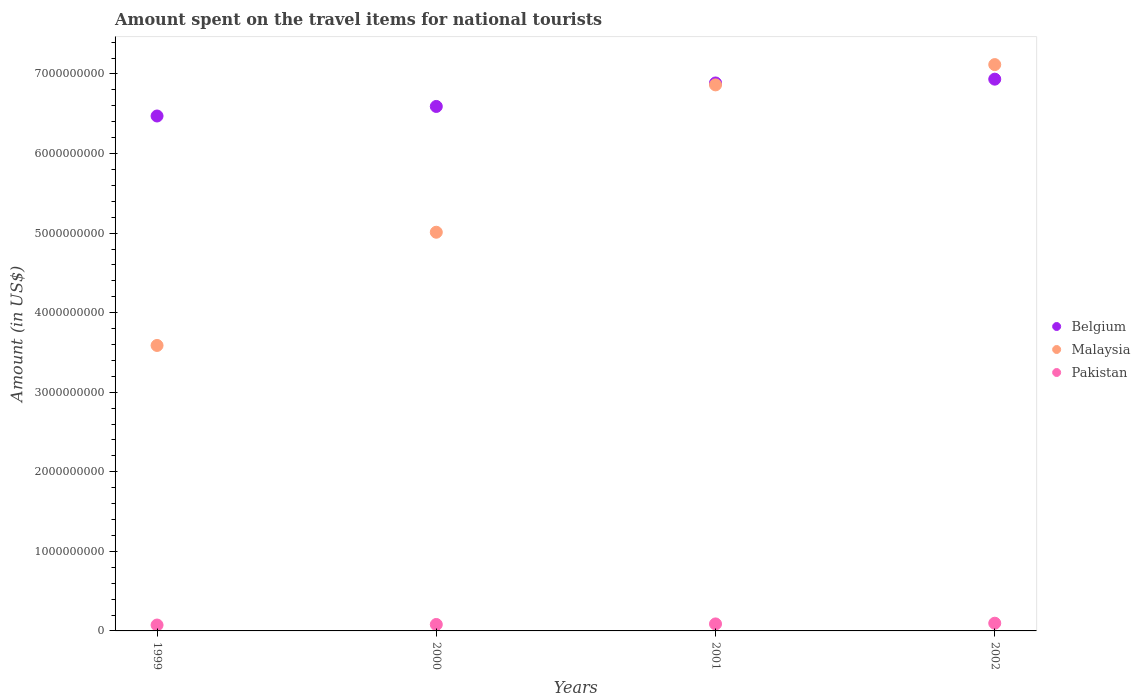How many different coloured dotlines are there?
Offer a terse response. 3. What is the amount spent on the travel items for national tourists in Belgium in 2001?
Make the answer very short. 6.89e+09. Across all years, what is the maximum amount spent on the travel items for national tourists in Belgium?
Keep it short and to the point. 6.94e+09. Across all years, what is the minimum amount spent on the travel items for national tourists in Pakistan?
Offer a terse response. 7.40e+07. What is the total amount spent on the travel items for national tourists in Belgium in the graph?
Your answer should be very brief. 2.69e+1. What is the difference between the amount spent on the travel items for national tourists in Belgium in 2000 and that in 2001?
Your answer should be very brief. -2.95e+08. What is the difference between the amount spent on the travel items for national tourists in Malaysia in 2002 and the amount spent on the travel items for national tourists in Belgium in 2000?
Your answer should be very brief. 5.26e+08. What is the average amount spent on the travel items for national tourists in Belgium per year?
Your response must be concise. 6.72e+09. In the year 2000, what is the difference between the amount spent on the travel items for national tourists in Malaysia and amount spent on the travel items for national tourists in Belgium?
Give a very brief answer. -1.58e+09. In how many years, is the amount spent on the travel items for national tourists in Belgium greater than 3000000000 US$?
Provide a succinct answer. 4. What is the ratio of the amount spent on the travel items for national tourists in Malaysia in 1999 to that in 2001?
Offer a terse response. 0.52. Is the amount spent on the travel items for national tourists in Belgium in 2000 less than that in 2002?
Your answer should be very brief. Yes. Is the difference between the amount spent on the travel items for national tourists in Malaysia in 1999 and 2001 greater than the difference between the amount spent on the travel items for national tourists in Belgium in 1999 and 2001?
Ensure brevity in your answer.  No. What is the difference between the highest and the second highest amount spent on the travel items for national tourists in Belgium?
Give a very brief answer. 4.80e+07. What is the difference between the highest and the lowest amount spent on the travel items for national tourists in Pakistan?
Provide a succinct answer. 2.30e+07. In how many years, is the amount spent on the travel items for national tourists in Belgium greater than the average amount spent on the travel items for national tourists in Belgium taken over all years?
Ensure brevity in your answer.  2. Does the amount spent on the travel items for national tourists in Belgium monotonically increase over the years?
Provide a short and direct response. Yes. Is the amount spent on the travel items for national tourists in Pakistan strictly less than the amount spent on the travel items for national tourists in Malaysia over the years?
Your answer should be compact. Yes. Does the graph contain any zero values?
Your answer should be very brief. No. Where does the legend appear in the graph?
Your answer should be compact. Center right. How are the legend labels stacked?
Keep it short and to the point. Vertical. What is the title of the graph?
Make the answer very short. Amount spent on the travel items for national tourists. Does "Chad" appear as one of the legend labels in the graph?
Provide a short and direct response. No. What is the label or title of the Y-axis?
Keep it short and to the point. Amount (in US$). What is the Amount (in US$) in Belgium in 1999?
Your answer should be compact. 6.47e+09. What is the Amount (in US$) in Malaysia in 1999?
Give a very brief answer. 3.59e+09. What is the Amount (in US$) of Pakistan in 1999?
Your answer should be very brief. 7.40e+07. What is the Amount (in US$) in Belgium in 2000?
Keep it short and to the point. 6.59e+09. What is the Amount (in US$) of Malaysia in 2000?
Your response must be concise. 5.01e+09. What is the Amount (in US$) of Pakistan in 2000?
Offer a terse response. 8.10e+07. What is the Amount (in US$) of Belgium in 2001?
Your answer should be compact. 6.89e+09. What is the Amount (in US$) in Malaysia in 2001?
Your response must be concise. 6.86e+09. What is the Amount (in US$) of Pakistan in 2001?
Your answer should be compact. 8.80e+07. What is the Amount (in US$) of Belgium in 2002?
Keep it short and to the point. 6.94e+09. What is the Amount (in US$) of Malaysia in 2002?
Provide a short and direct response. 7.12e+09. What is the Amount (in US$) of Pakistan in 2002?
Offer a terse response. 9.70e+07. Across all years, what is the maximum Amount (in US$) of Belgium?
Provide a succinct answer. 6.94e+09. Across all years, what is the maximum Amount (in US$) in Malaysia?
Offer a very short reply. 7.12e+09. Across all years, what is the maximum Amount (in US$) in Pakistan?
Ensure brevity in your answer.  9.70e+07. Across all years, what is the minimum Amount (in US$) in Belgium?
Offer a terse response. 6.47e+09. Across all years, what is the minimum Amount (in US$) of Malaysia?
Make the answer very short. 3.59e+09. Across all years, what is the minimum Amount (in US$) of Pakistan?
Provide a short and direct response. 7.40e+07. What is the total Amount (in US$) in Belgium in the graph?
Keep it short and to the point. 2.69e+1. What is the total Amount (in US$) of Malaysia in the graph?
Your answer should be very brief. 2.26e+1. What is the total Amount (in US$) in Pakistan in the graph?
Keep it short and to the point. 3.40e+08. What is the difference between the Amount (in US$) of Belgium in 1999 and that in 2000?
Keep it short and to the point. -1.20e+08. What is the difference between the Amount (in US$) in Malaysia in 1999 and that in 2000?
Your answer should be very brief. -1.42e+09. What is the difference between the Amount (in US$) in Pakistan in 1999 and that in 2000?
Your answer should be very brief. -7.00e+06. What is the difference between the Amount (in US$) in Belgium in 1999 and that in 2001?
Give a very brief answer. -4.15e+08. What is the difference between the Amount (in US$) of Malaysia in 1999 and that in 2001?
Make the answer very short. -3.28e+09. What is the difference between the Amount (in US$) in Pakistan in 1999 and that in 2001?
Offer a very short reply. -1.40e+07. What is the difference between the Amount (in US$) of Belgium in 1999 and that in 2002?
Offer a very short reply. -4.63e+08. What is the difference between the Amount (in US$) of Malaysia in 1999 and that in 2002?
Ensure brevity in your answer.  -3.53e+09. What is the difference between the Amount (in US$) of Pakistan in 1999 and that in 2002?
Offer a terse response. -2.30e+07. What is the difference between the Amount (in US$) in Belgium in 2000 and that in 2001?
Provide a succinct answer. -2.95e+08. What is the difference between the Amount (in US$) in Malaysia in 2000 and that in 2001?
Offer a very short reply. -1.85e+09. What is the difference between the Amount (in US$) of Pakistan in 2000 and that in 2001?
Make the answer very short. -7.00e+06. What is the difference between the Amount (in US$) in Belgium in 2000 and that in 2002?
Make the answer very short. -3.43e+08. What is the difference between the Amount (in US$) in Malaysia in 2000 and that in 2002?
Your response must be concise. -2.11e+09. What is the difference between the Amount (in US$) in Pakistan in 2000 and that in 2002?
Provide a succinct answer. -1.60e+07. What is the difference between the Amount (in US$) in Belgium in 2001 and that in 2002?
Your answer should be very brief. -4.80e+07. What is the difference between the Amount (in US$) of Malaysia in 2001 and that in 2002?
Give a very brief answer. -2.55e+08. What is the difference between the Amount (in US$) of Pakistan in 2001 and that in 2002?
Give a very brief answer. -9.00e+06. What is the difference between the Amount (in US$) in Belgium in 1999 and the Amount (in US$) in Malaysia in 2000?
Offer a terse response. 1.46e+09. What is the difference between the Amount (in US$) of Belgium in 1999 and the Amount (in US$) of Pakistan in 2000?
Make the answer very short. 6.39e+09. What is the difference between the Amount (in US$) of Malaysia in 1999 and the Amount (in US$) of Pakistan in 2000?
Offer a terse response. 3.51e+09. What is the difference between the Amount (in US$) of Belgium in 1999 and the Amount (in US$) of Malaysia in 2001?
Give a very brief answer. -3.91e+08. What is the difference between the Amount (in US$) in Belgium in 1999 and the Amount (in US$) in Pakistan in 2001?
Your response must be concise. 6.38e+09. What is the difference between the Amount (in US$) in Malaysia in 1999 and the Amount (in US$) in Pakistan in 2001?
Offer a terse response. 3.50e+09. What is the difference between the Amount (in US$) of Belgium in 1999 and the Amount (in US$) of Malaysia in 2002?
Your answer should be compact. -6.46e+08. What is the difference between the Amount (in US$) in Belgium in 1999 and the Amount (in US$) in Pakistan in 2002?
Make the answer very short. 6.38e+09. What is the difference between the Amount (in US$) of Malaysia in 1999 and the Amount (in US$) of Pakistan in 2002?
Your response must be concise. 3.49e+09. What is the difference between the Amount (in US$) of Belgium in 2000 and the Amount (in US$) of Malaysia in 2001?
Provide a succinct answer. -2.71e+08. What is the difference between the Amount (in US$) of Belgium in 2000 and the Amount (in US$) of Pakistan in 2001?
Give a very brief answer. 6.50e+09. What is the difference between the Amount (in US$) of Malaysia in 2000 and the Amount (in US$) of Pakistan in 2001?
Give a very brief answer. 4.92e+09. What is the difference between the Amount (in US$) in Belgium in 2000 and the Amount (in US$) in Malaysia in 2002?
Provide a short and direct response. -5.26e+08. What is the difference between the Amount (in US$) of Belgium in 2000 and the Amount (in US$) of Pakistan in 2002?
Offer a terse response. 6.50e+09. What is the difference between the Amount (in US$) in Malaysia in 2000 and the Amount (in US$) in Pakistan in 2002?
Your answer should be compact. 4.91e+09. What is the difference between the Amount (in US$) in Belgium in 2001 and the Amount (in US$) in Malaysia in 2002?
Offer a terse response. -2.31e+08. What is the difference between the Amount (in US$) of Belgium in 2001 and the Amount (in US$) of Pakistan in 2002?
Make the answer very short. 6.79e+09. What is the difference between the Amount (in US$) of Malaysia in 2001 and the Amount (in US$) of Pakistan in 2002?
Give a very brief answer. 6.77e+09. What is the average Amount (in US$) in Belgium per year?
Your response must be concise. 6.72e+09. What is the average Amount (in US$) in Malaysia per year?
Your answer should be very brief. 5.64e+09. What is the average Amount (in US$) of Pakistan per year?
Keep it short and to the point. 8.50e+07. In the year 1999, what is the difference between the Amount (in US$) of Belgium and Amount (in US$) of Malaysia?
Your answer should be very brief. 2.88e+09. In the year 1999, what is the difference between the Amount (in US$) of Belgium and Amount (in US$) of Pakistan?
Provide a succinct answer. 6.40e+09. In the year 1999, what is the difference between the Amount (in US$) in Malaysia and Amount (in US$) in Pakistan?
Give a very brief answer. 3.51e+09. In the year 2000, what is the difference between the Amount (in US$) in Belgium and Amount (in US$) in Malaysia?
Provide a succinct answer. 1.58e+09. In the year 2000, what is the difference between the Amount (in US$) of Belgium and Amount (in US$) of Pakistan?
Keep it short and to the point. 6.51e+09. In the year 2000, what is the difference between the Amount (in US$) in Malaysia and Amount (in US$) in Pakistan?
Offer a very short reply. 4.93e+09. In the year 2001, what is the difference between the Amount (in US$) of Belgium and Amount (in US$) of Malaysia?
Make the answer very short. 2.40e+07. In the year 2001, what is the difference between the Amount (in US$) in Belgium and Amount (in US$) in Pakistan?
Ensure brevity in your answer.  6.80e+09. In the year 2001, what is the difference between the Amount (in US$) of Malaysia and Amount (in US$) of Pakistan?
Ensure brevity in your answer.  6.78e+09. In the year 2002, what is the difference between the Amount (in US$) of Belgium and Amount (in US$) of Malaysia?
Ensure brevity in your answer.  -1.83e+08. In the year 2002, what is the difference between the Amount (in US$) in Belgium and Amount (in US$) in Pakistan?
Your answer should be compact. 6.84e+09. In the year 2002, what is the difference between the Amount (in US$) of Malaysia and Amount (in US$) of Pakistan?
Your answer should be very brief. 7.02e+09. What is the ratio of the Amount (in US$) of Belgium in 1999 to that in 2000?
Offer a very short reply. 0.98. What is the ratio of the Amount (in US$) in Malaysia in 1999 to that in 2000?
Provide a succinct answer. 0.72. What is the ratio of the Amount (in US$) in Pakistan in 1999 to that in 2000?
Your answer should be compact. 0.91. What is the ratio of the Amount (in US$) in Belgium in 1999 to that in 2001?
Provide a succinct answer. 0.94. What is the ratio of the Amount (in US$) of Malaysia in 1999 to that in 2001?
Provide a succinct answer. 0.52. What is the ratio of the Amount (in US$) of Pakistan in 1999 to that in 2001?
Give a very brief answer. 0.84. What is the ratio of the Amount (in US$) in Belgium in 1999 to that in 2002?
Make the answer very short. 0.93. What is the ratio of the Amount (in US$) of Malaysia in 1999 to that in 2002?
Keep it short and to the point. 0.5. What is the ratio of the Amount (in US$) of Pakistan in 1999 to that in 2002?
Provide a succinct answer. 0.76. What is the ratio of the Amount (in US$) in Belgium in 2000 to that in 2001?
Provide a short and direct response. 0.96. What is the ratio of the Amount (in US$) of Malaysia in 2000 to that in 2001?
Provide a succinct answer. 0.73. What is the ratio of the Amount (in US$) in Pakistan in 2000 to that in 2001?
Offer a very short reply. 0.92. What is the ratio of the Amount (in US$) of Belgium in 2000 to that in 2002?
Offer a very short reply. 0.95. What is the ratio of the Amount (in US$) in Malaysia in 2000 to that in 2002?
Offer a terse response. 0.7. What is the ratio of the Amount (in US$) in Pakistan in 2000 to that in 2002?
Make the answer very short. 0.84. What is the ratio of the Amount (in US$) of Malaysia in 2001 to that in 2002?
Provide a short and direct response. 0.96. What is the ratio of the Amount (in US$) in Pakistan in 2001 to that in 2002?
Ensure brevity in your answer.  0.91. What is the difference between the highest and the second highest Amount (in US$) in Belgium?
Give a very brief answer. 4.80e+07. What is the difference between the highest and the second highest Amount (in US$) in Malaysia?
Give a very brief answer. 2.55e+08. What is the difference between the highest and the second highest Amount (in US$) of Pakistan?
Keep it short and to the point. 9.00e+06. What is the difference between the highest and the lowest Amount (in US$) in Belgium?
Ensure brevity in your answer.  4.63e+08. What is the difference between the highest and the lowest Amount (in US$) in Malaysia?
Your answer should be compact. 3.53e+09. What is the difference between the highest and the lowest Amount (in US$) of Pakistan?
Ensure brevity in your answer.  2.30e+07. 